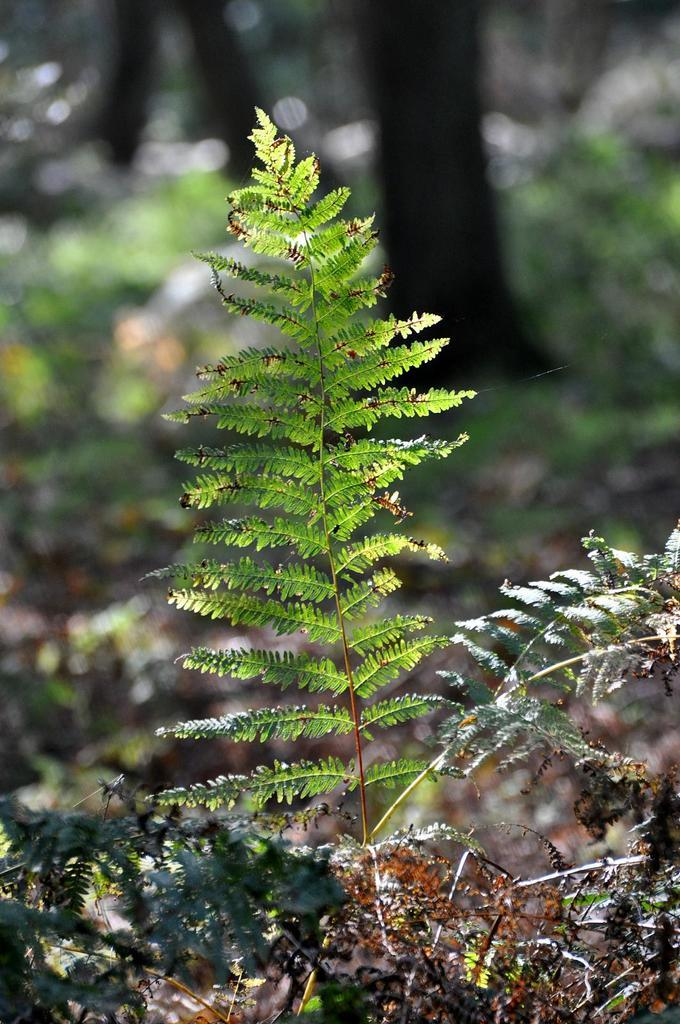What is present in the image? There is a plant in the image. What can be said about the color of the plant? The plant is green in color. What type of letter is being delivered in the image? There is no letter or delivery depicted in the image; it only features a green plant. 